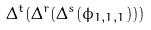Convert formula to latex. <formula><loc_0><loc_0><loc_500><loc_500>\Delta ^ { t } ( \Delta ^ { r } ( \Delta ^ { s } ( \phi _ { 1 , 1 , 1 } ) ) )</formula> 